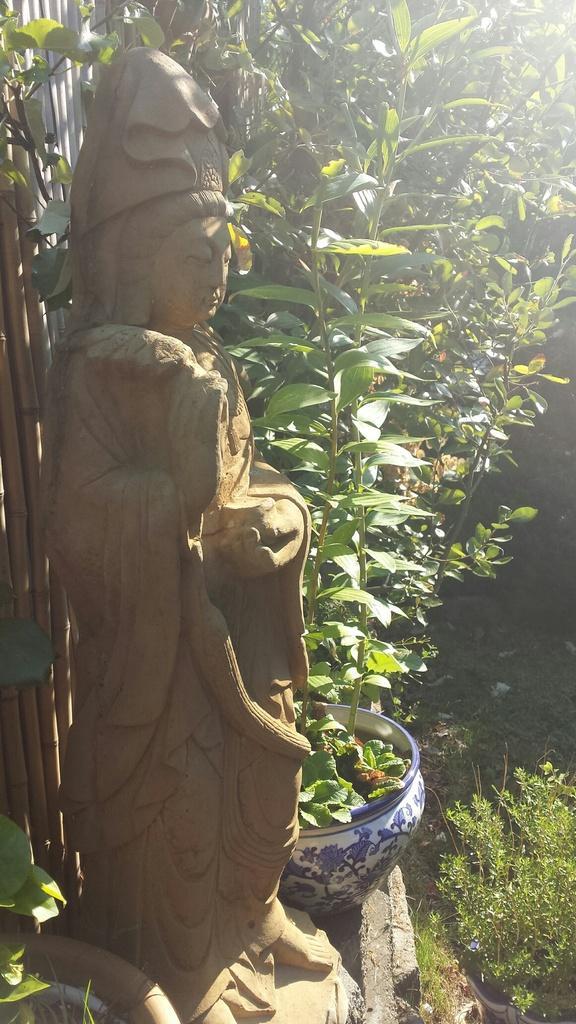Describe this image in one or two sentences. On the left side there is a statue, in the middle there are plants and trees. 